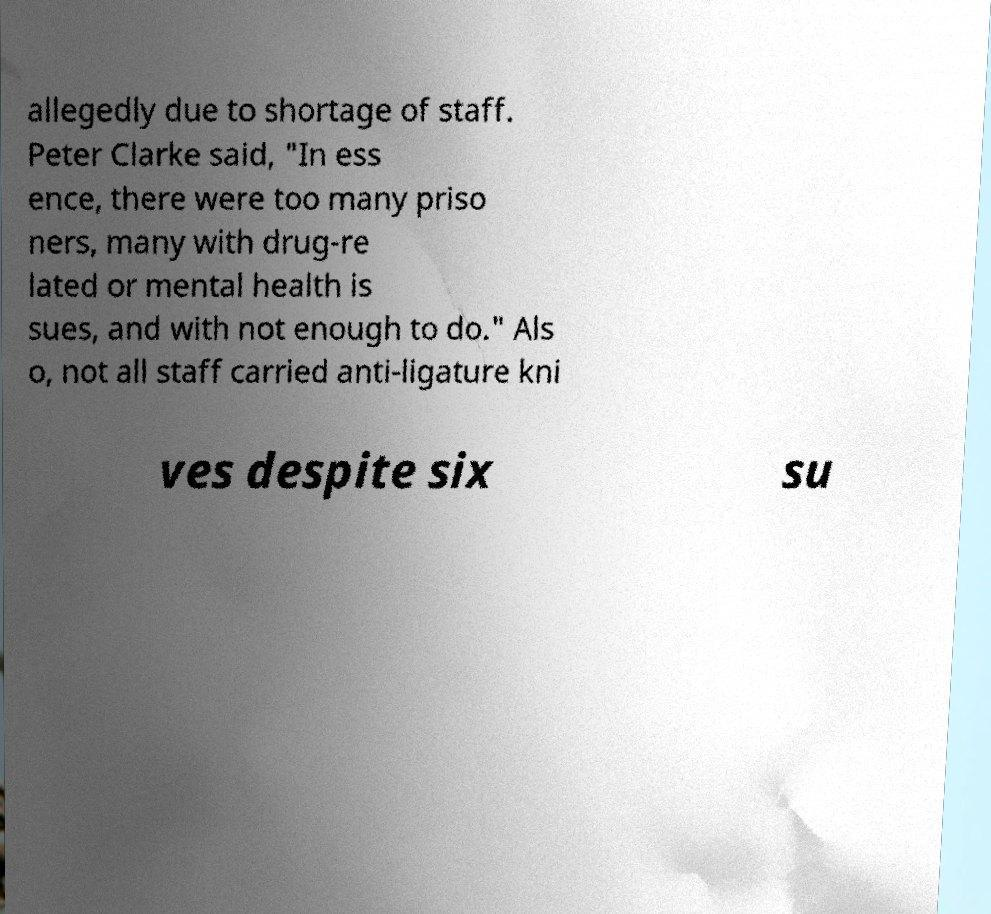Could you assist in decoding the text presented in this image and type it out clearly? allegedly due to shortage of staff. Peter Clarke said, "In ess ence, there were too many priso ners, many with drug-re lated or mental health is sues, and with not enough to do." Als o, not all staff carried anti-ligature kni ves despite six su 